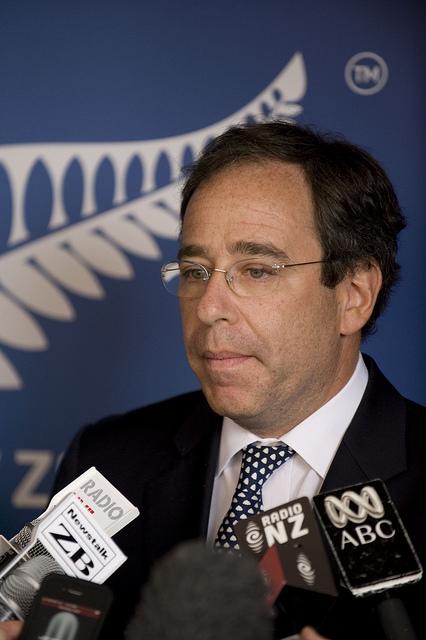What is the letters on the black microphone?
Short answer required. Abc. What is on the man's face?
Answer briefly. Glasses. Why is the man speaking at the microphone?
Answer briefly. Press conference. What color is the background?
Quick response, please. Blue and white. 